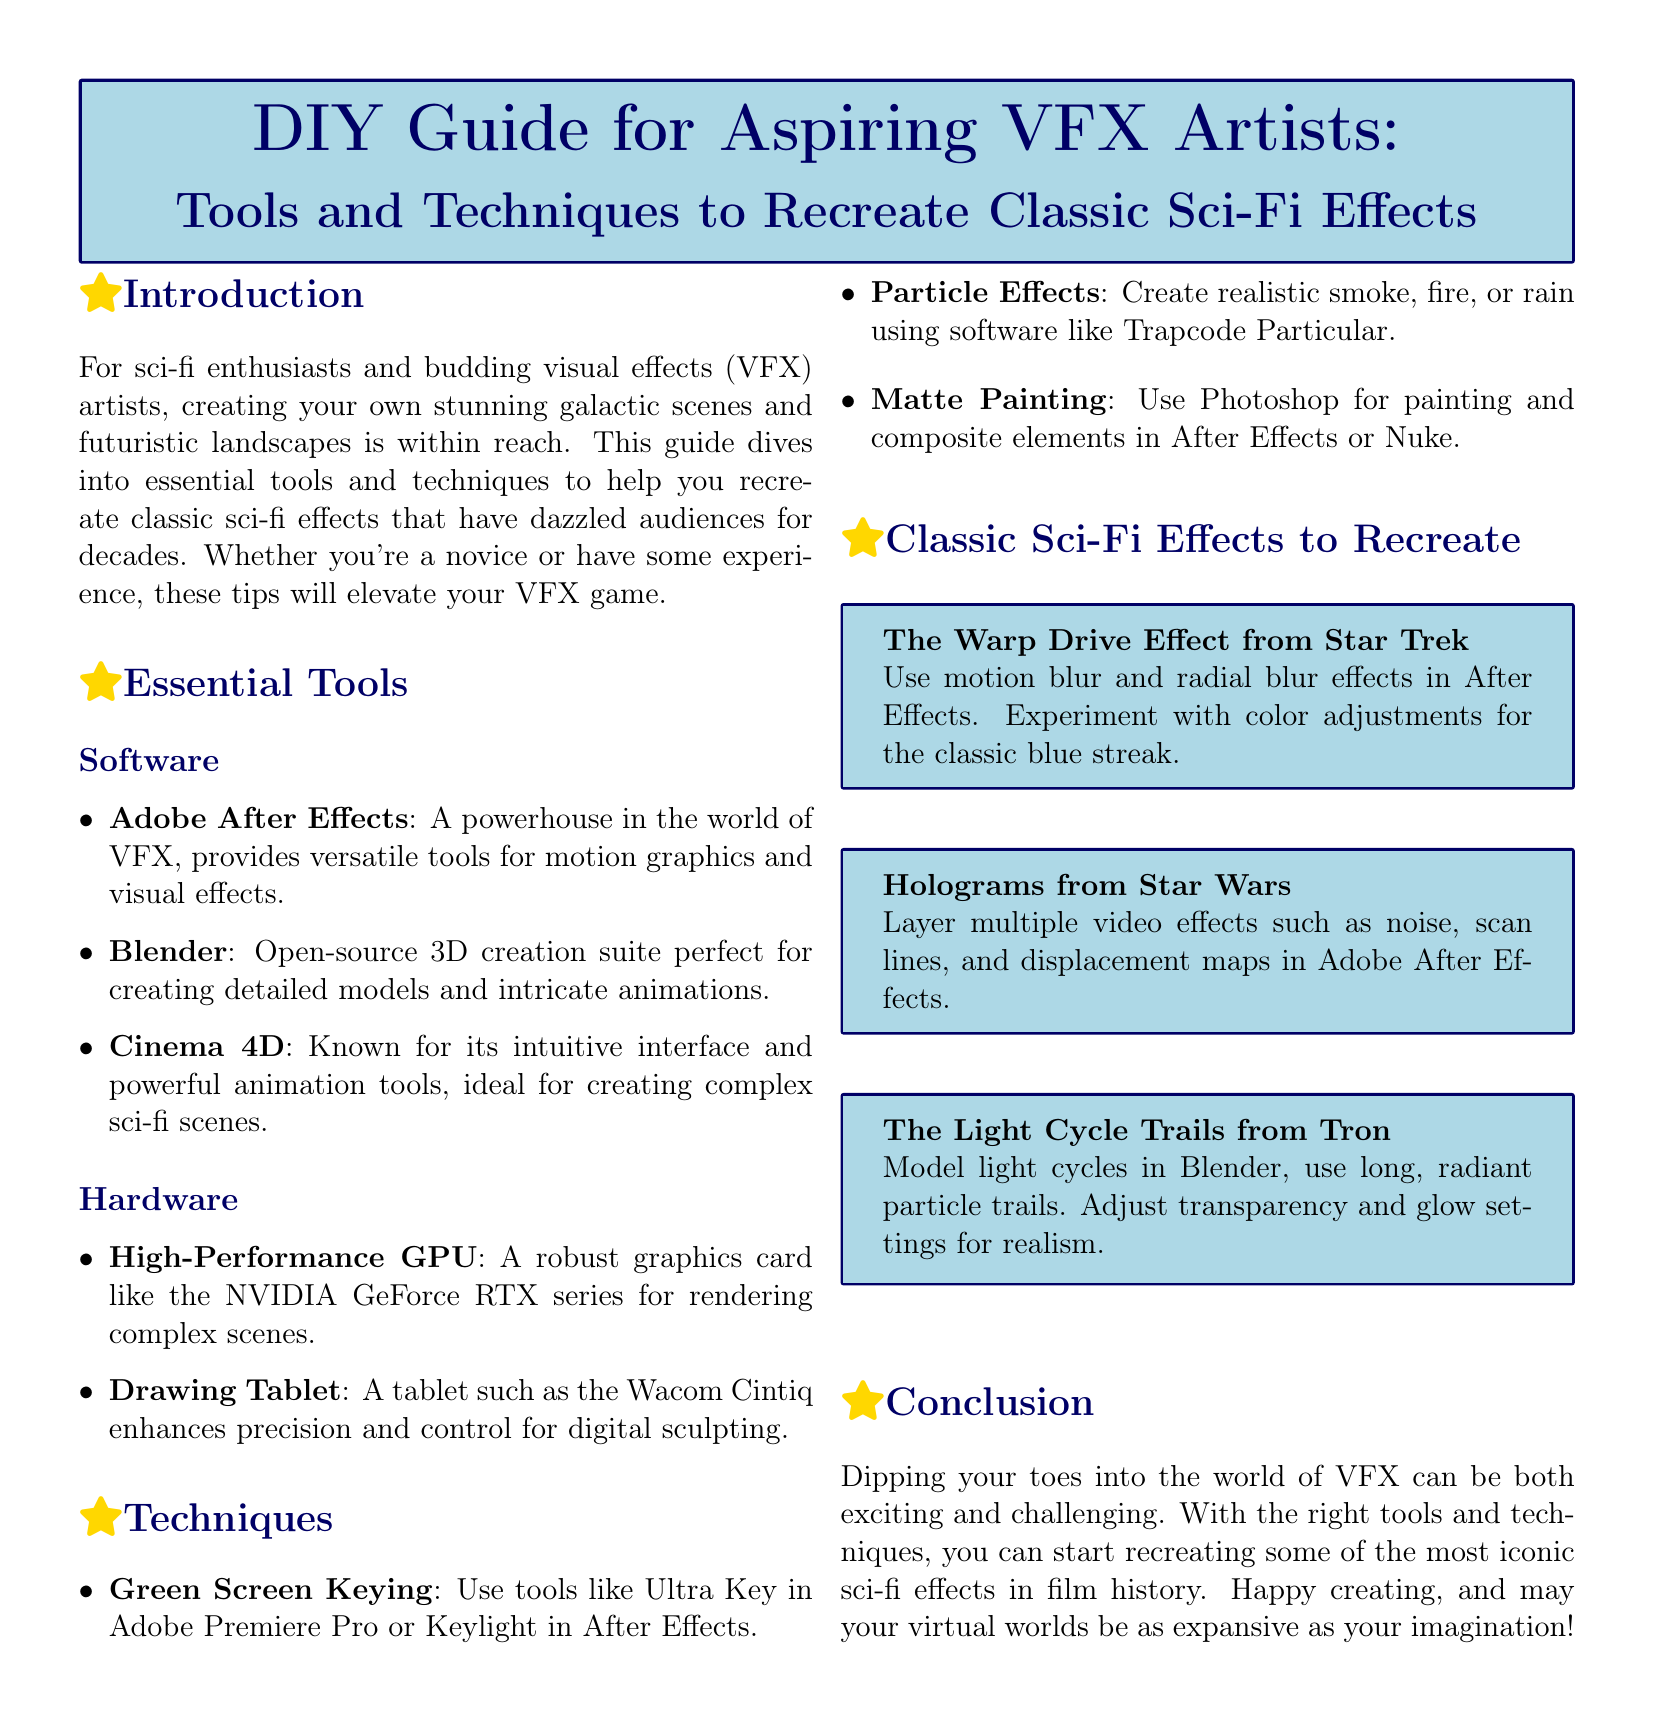What is the title of the guide? The title of the guide is prominently displayed at the top of the document in a specific format.
Answer: DIY Guide for Aspiring VFX Artists: Tools and Techniques to Recreate Classic Sci-Fi Effects Which software is recommended for particle effects? The document lists various software tools under the "Essential Tools" section, mentioning specific functions.
Answer: Trapcode Particular What are the two types of hardware mentioned? The guide categorizes recommended tools into software and hardware, itemizing key hardware components.
Answer: High-Performance GPU, Drawing Tablet How many classic sci-fi effects are showcased in the document? The document lists several classic sci-fi effects alongside descriptions of how to recreate them.
Answer: Three What effect can be recreated using motion blur and radial blur? The specifics of recreating effects are noted within the Classic Sci-Fi Effects section for clarity and precision.
Answer: The Warp Drive Effect from Star Trek In which software can you create detailed models and animations? The document provides a list of software tools, highlighting those suitable for creating detailed visuals.
Answer: Blender What kind of tablet enhances precision for digital sculpting? The guide specifically mentions types of hardware and their benefits for aspiring artists.
Answer: Wacom Cintiq What technique is suggested for creating holograms? Techniques are outlined in the "Techniques" section, covering various methods for achieving visual effects.
Answer: Layer multiple video effects 